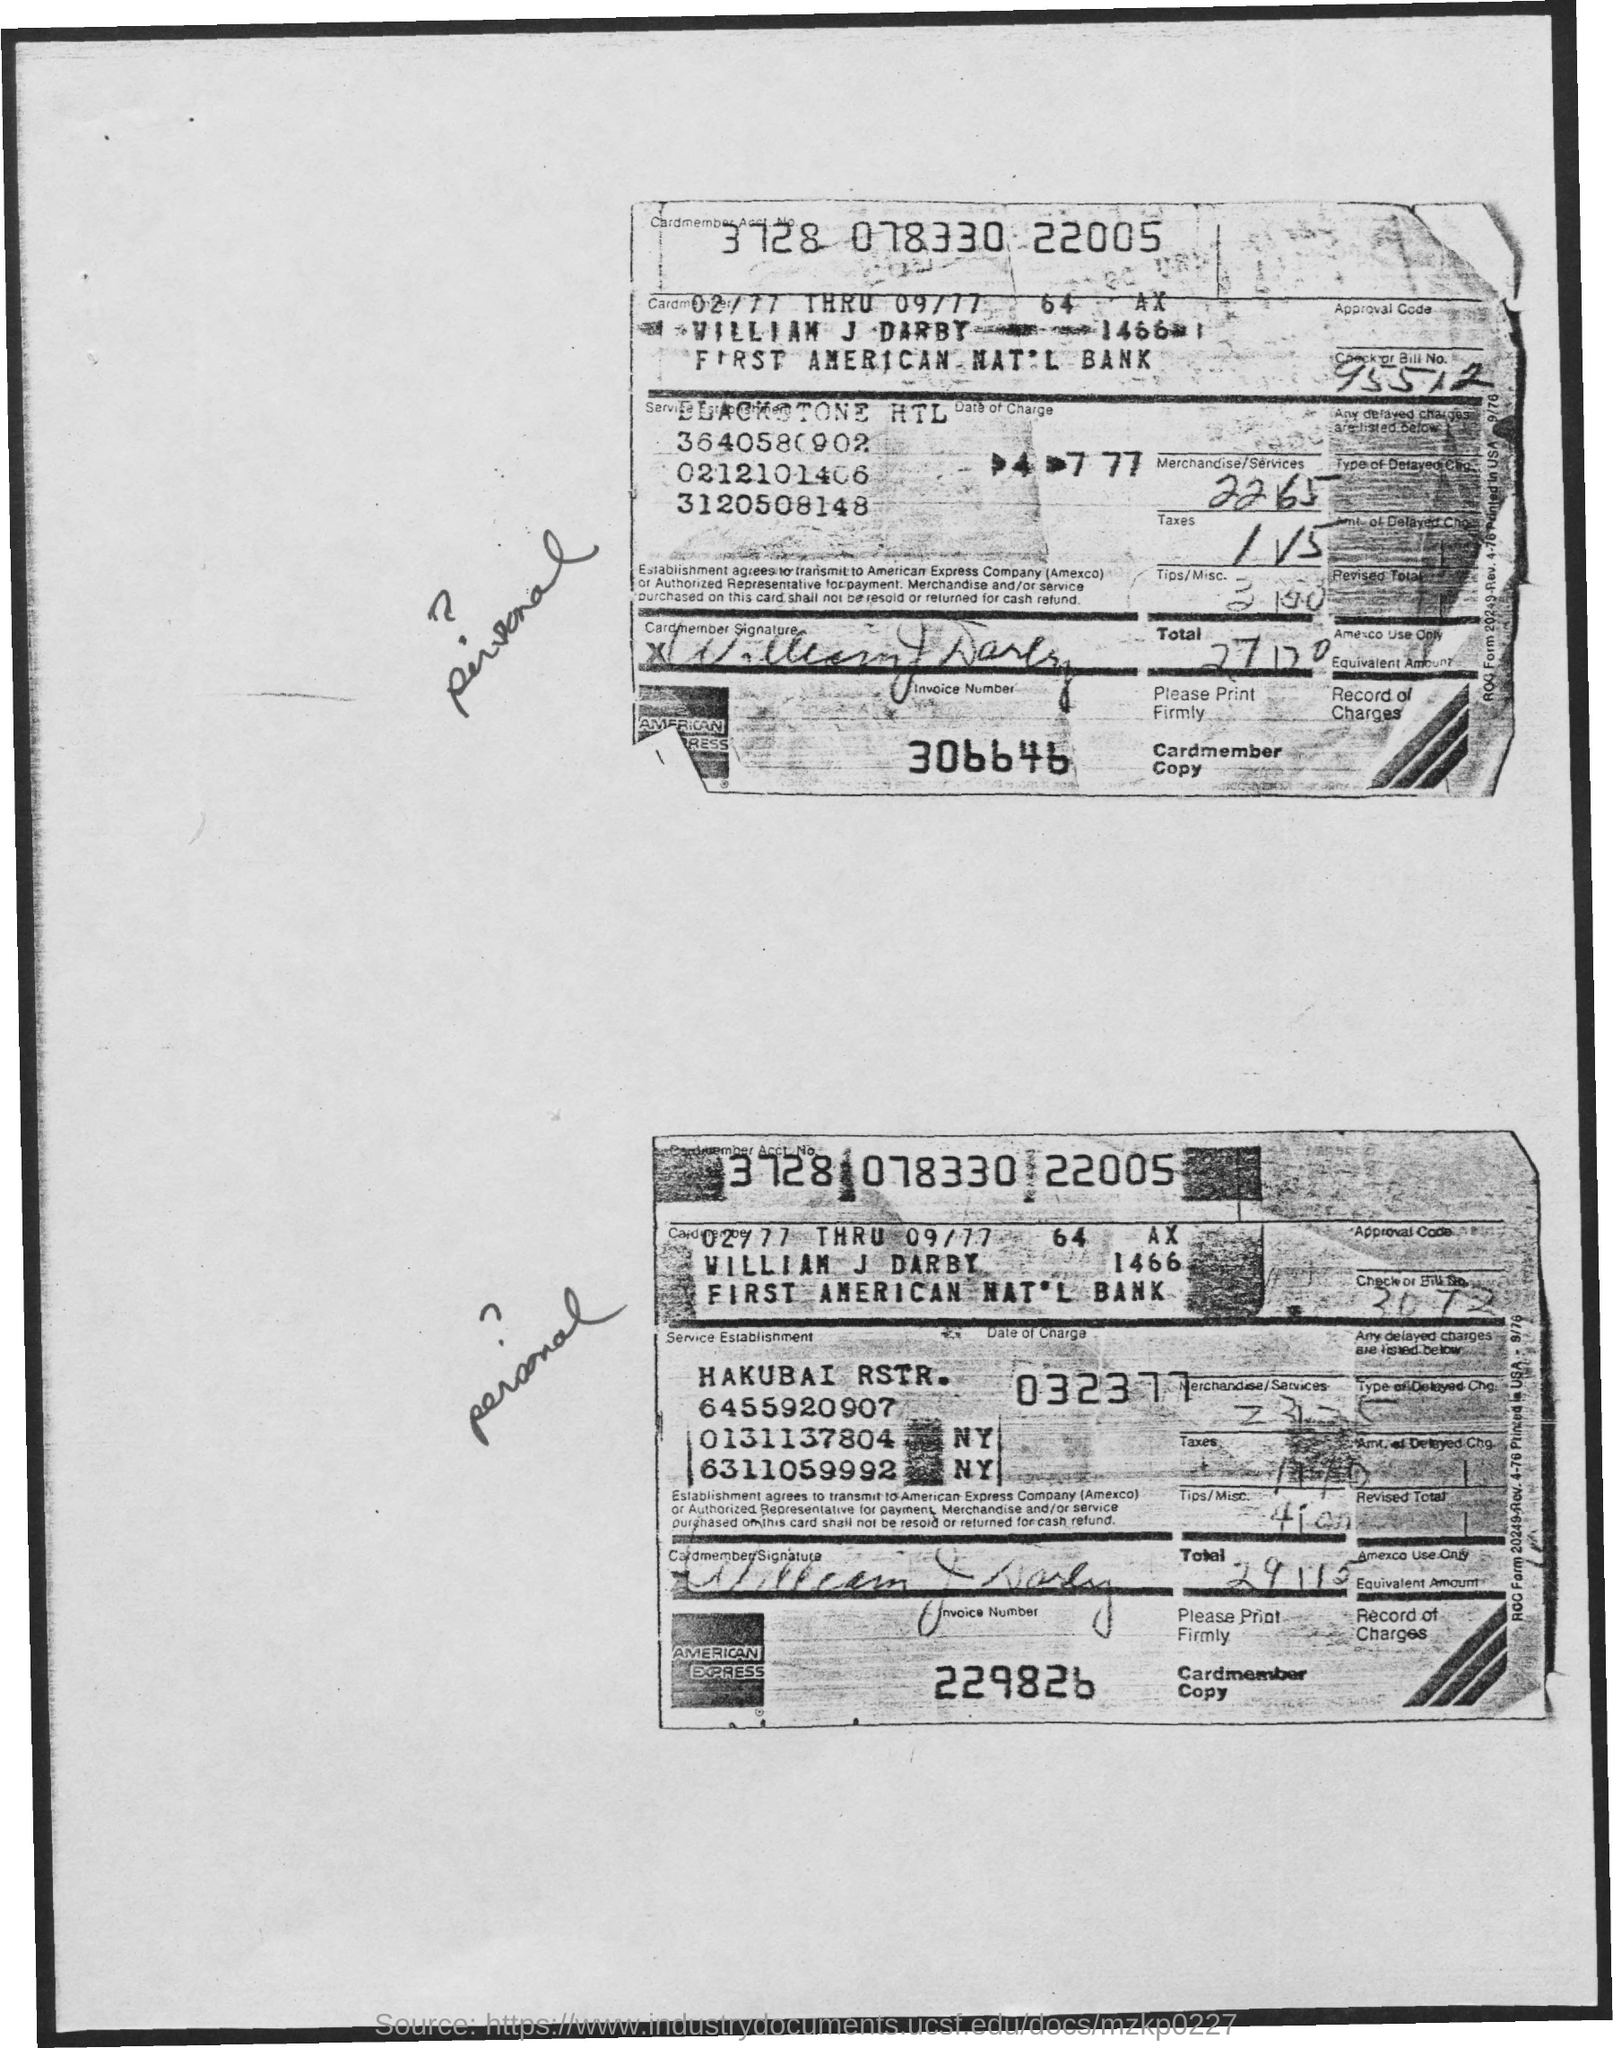Mention a couple of crucial points in this snapshot. Can you please provide the check or bill number that is located at the top of the first copy? The cardmember is William J. Darby. The cardmember account number is 3728 078330 22005. The invoice number on the first page from the top is 306646. 